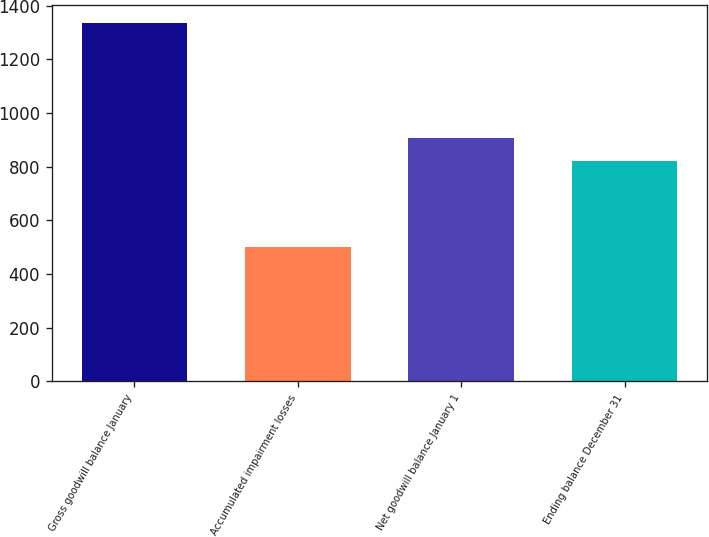<chart> <loc_0><loc_0><loc_500><loc_500><bar_chart><fcel>Gross goodwill balance January<fcel>Accumulated impairment losses<fcel>Net goodwill balance January 1<fcel>Ending balance December 31<nl><fcel>1334.7<fcel>501.8<fcel>905.59<fcel>822.3<nl></chart> 